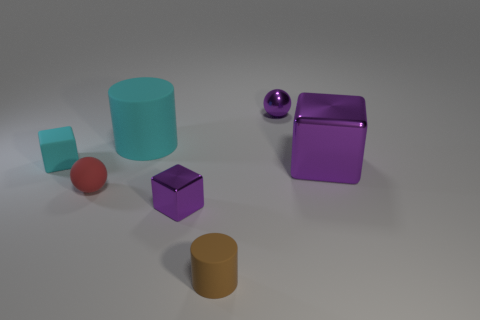Are there an equal number of small red objects behind the purple sphere and big purple matte things?
Provide a short and direct response. Yes. Is the size of the red rubber sphere the same as the cyan rubber cylinder?
Your answer should be compact. No. The tiny thing that is behind the big shiny object and in front of the big cyan object is made of what material?
Offer a very short reply. Rubber. What number of gray rubber objects are the same shape as the small red object?
Your response must be concise. 0. There is a tiny purple object that is to the right of the brown cylinder; what material is it?
Offer a very short reply. Metal. Are there fewer tiny rubber cylinders in front of the small purple shiny cube than small red objects?
Provide a succinct answer. No. Is the shape of the big matte thing the same as the small brown matte thing?
Make the answer very short. Yes. Are any large green objects visible?
Make the answer very short. No. There is a tiny red rubber object; is it the same shape as the cyan matte thing that is right of the tiny cyan object?
Your answer should be very brief. No. What material is the big thing behind the cyan matte thing left of the tiny red object made of?
Ensure brevity in your answer.  Rubber. 